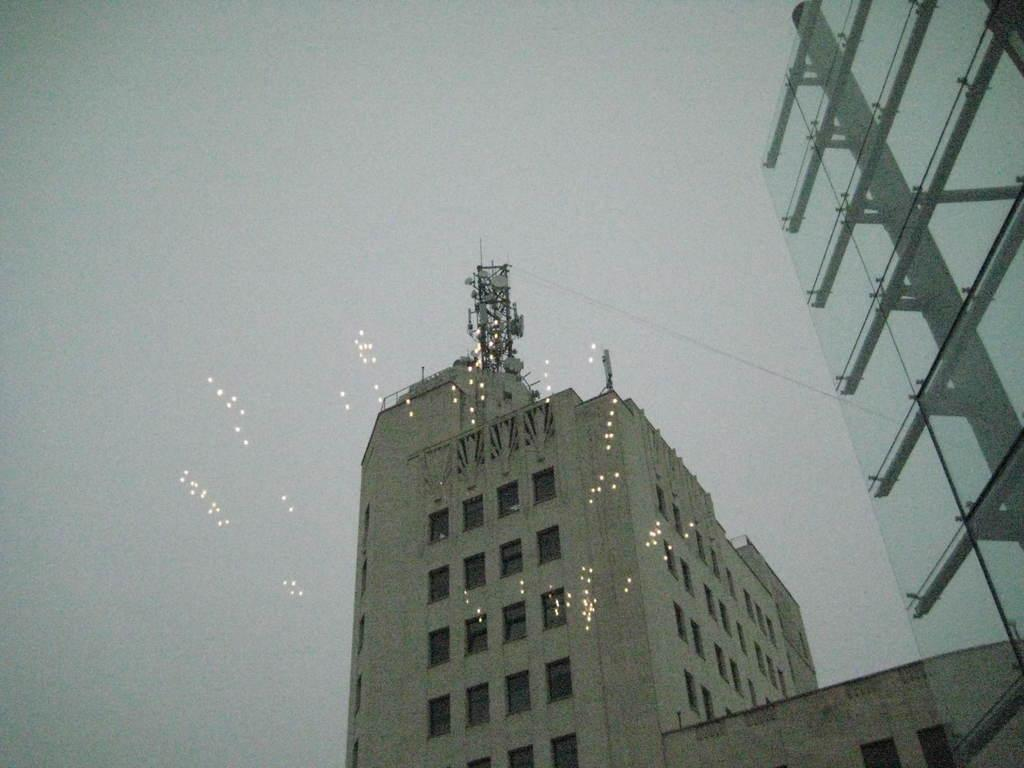What type of structures can be seen in the image? There are buildings in the image. What is the color of the sky in the image? The sky is white in color. How many mittens are hanging on the buildings in the image? There are no mittens present in the image; it only features buildings and a white sky. 